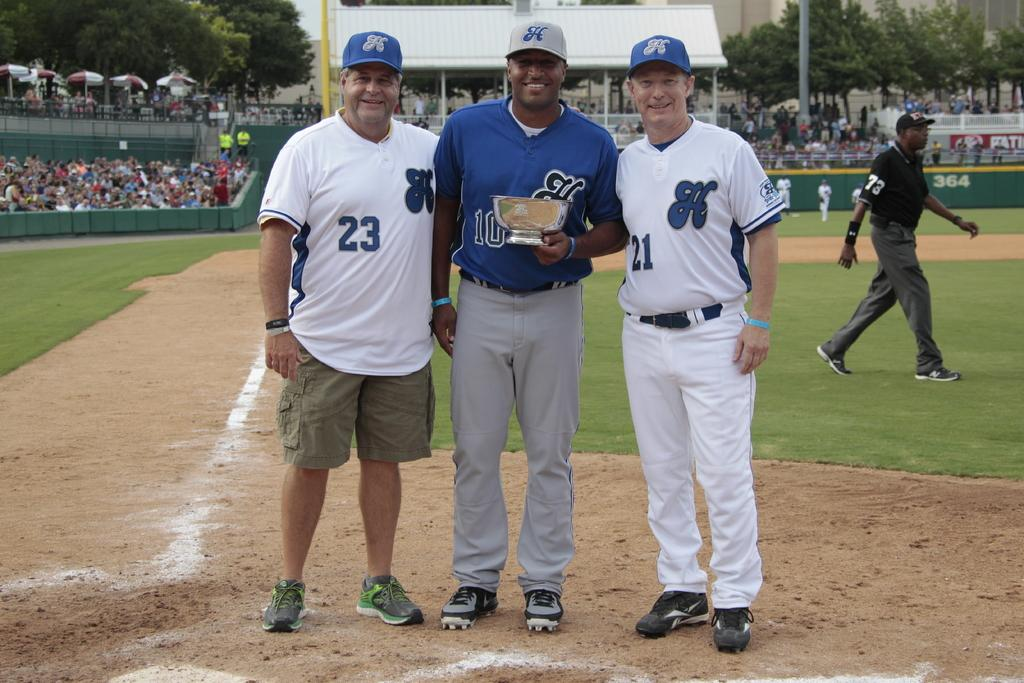<image>
Describe the image concisely. three players with one wearing the number 23 on it 